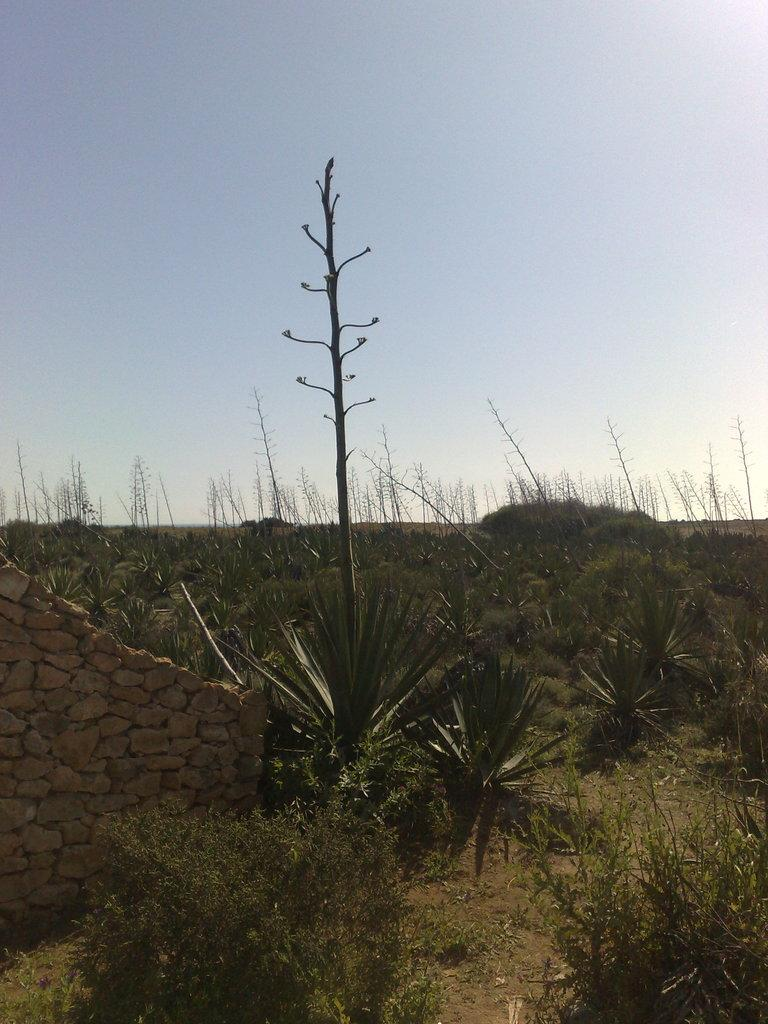What is on the surface in the image? There are plants on the surface in the image. What is the wall made of beside the surface with plants? The wall is made of rocks. Are there any plants visible behind the rock wall? Yes, there are plants visible behind the rock wall. What can be seen in the background of the image? The sky is visible in the background of the image. Can you describe the harmony between the sofa and the plants in the image? There is no sofa present in the image, so it is not possible to describe any harmony between it and the plants. 